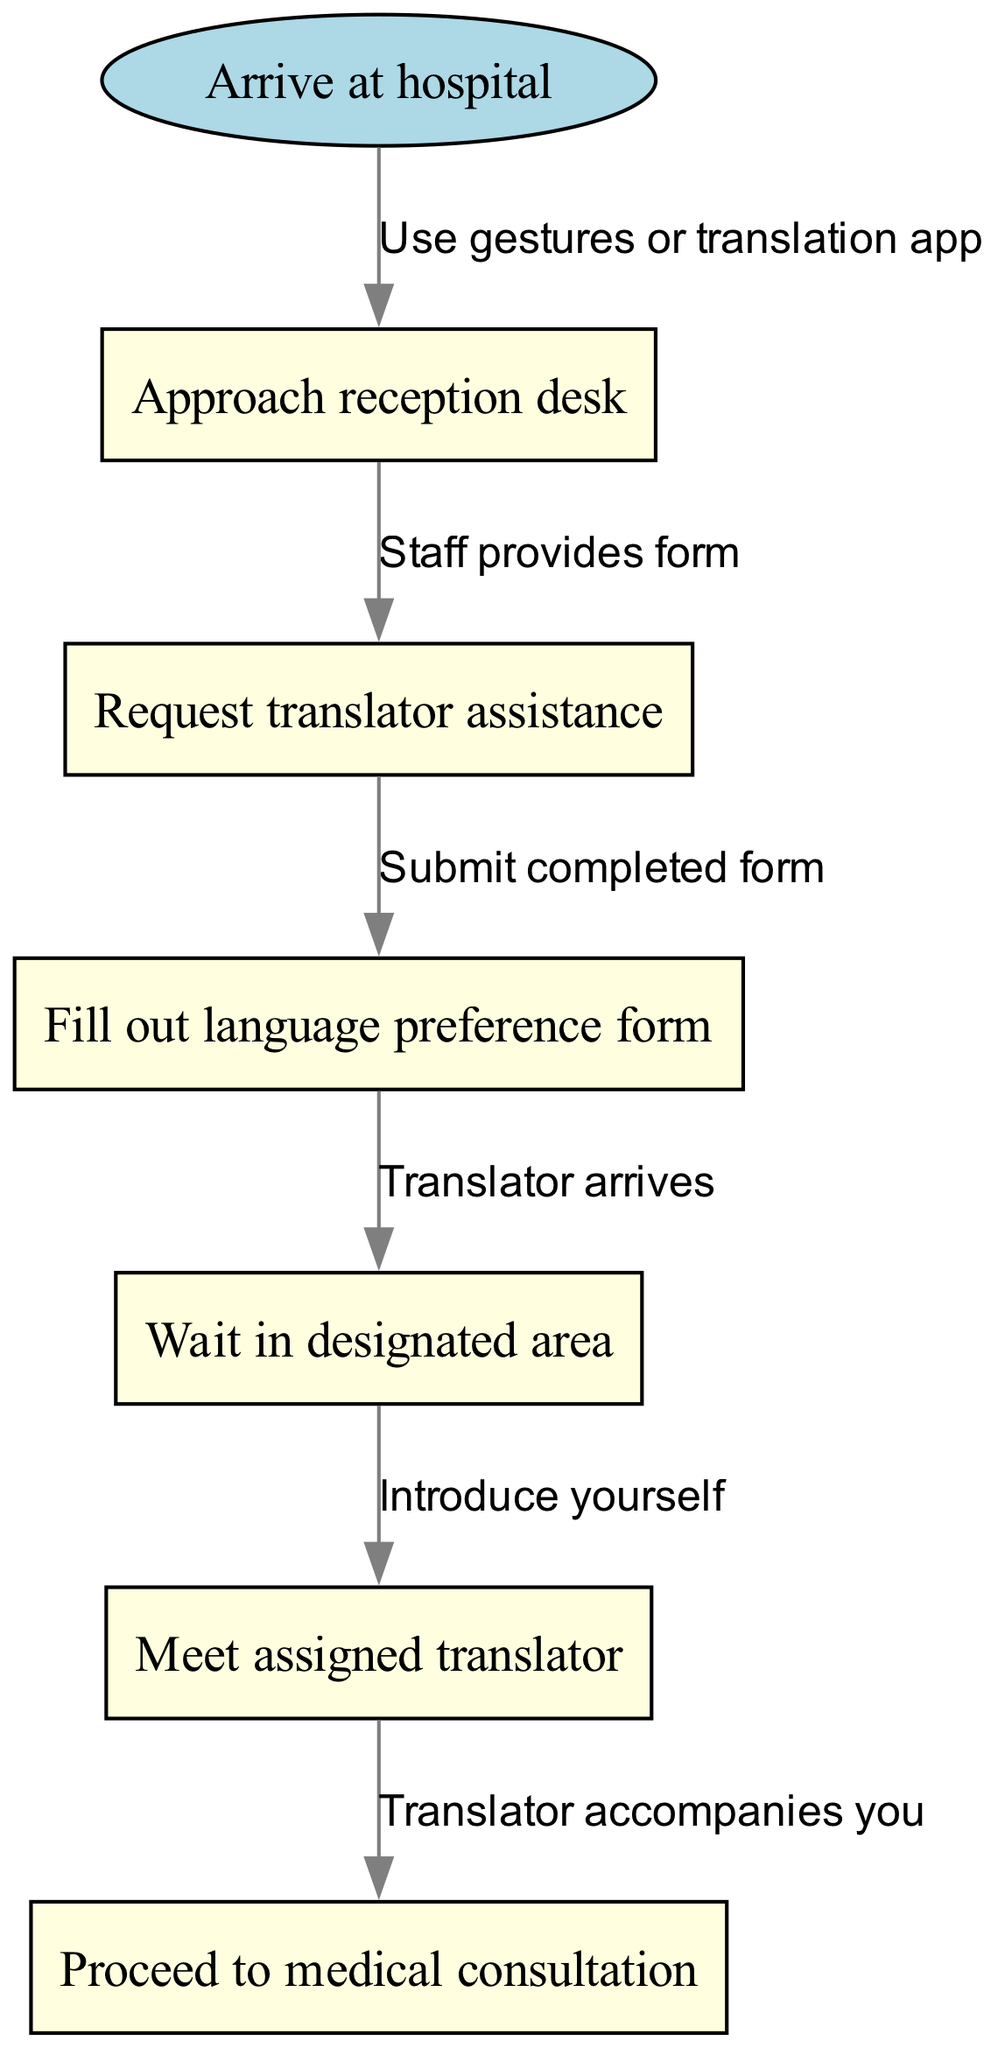What is the first step after arriving at the hospital? According to the flow chart, the first step indicated after "Arrive at hospital" is "Approach reception desk."
Answer: Approach reception desk How many nodes are present in the diagram? The diagram contains a total of 6 nodes including the start node and the five subsequent steps. Counting each node gives us 6.
Answer: 6 What action do you take after filling out the language preference form? After filling out the language preference form, the next step is to "Wait in designated area." This is shown as the direct connection to the next node.
Answer: Wait in designated area Which node directly follows “Request translator assistance”? Following “Request translator assistance,” the next node is "Fill out language preference form," which is indicated through a connecting edge.
Answer: Fill out language preference form What happens after meeting the assigned translator? After "Meet assigned translator," the flow chart indicates the next action is "Proceed to medical consultation," showing the final step in the process.
Answer: Proceed to medical consultation How many edges connect the nodes in the diagram? The diagram has 5 edges, as it shows the flow from start through to the last step, and there is one edge between each pair of nodes.
Answer: 5 What tool can be used if you cannot communicate verbally? The flow chart suggests using "gestures or translation app" as a means of communication if verbal interaction is not possible.
Answer: gestures or translation app What is the purpose of the language preference form? The language preference form is used to communicate your specific translation needs to the hospital staff so that they can provide the appropriate assistance.
Answer: communicate translation needs What do you do when the translator arrives? When the translator arrives, the next step is to "Introduce yourself," which prepares for the consultation process.
Answer: Introduce yourself 